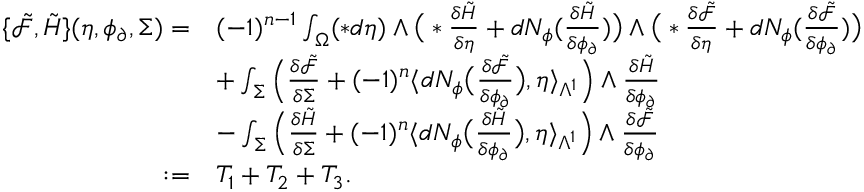<formula> <loc_0><loc_0><loc_500><loc_500>\begin{array} { r l } { \{ \tilde { \mathcal { F } } , \tilde { H } \} ( \eta , \phi _ { \partial } , \Sigma ) = } & { ( - 1 ) ^ { n - 1 } \int _ { \Omega } ( \ast d \eta ) \wedge \left ( \ast \frac { \delta \tilde { H } } { \delta \eta } + d N _ { \phi } ( \frac { \delta \tilde { H } } { \delta \phi _ { \partial } } ) \right ) \wedge \left ( \ast \frac { \delta \tilde { \mathcal { F } } } { \delta \eta } + d N _ { \phi } ( \frac { \delta \tilde { \mathcal { F } } } { \delta \phi _ { \partial } } ) \right ) } \\ & { + \int _ { \Sigma } \left ( \frac { \delta \tilde { \mathcal { F } } } { \delta \Sigma } + ( - 1 ) ^ { n } \langle d N _ { \phi } \left ( \frac { \delta \tilde { \mathcal { F } } } { \delta \phi _ { \partial } } \right ) , \eta \rangle _ { \Lambda ^ { 1 } } \right ) \wedge \frac { \delta \tilde { H } } { \delta \phi _ { \partial } } } \\ & { - \int _ { \Sigma } \left ( \frac { \delta \tilde { H } } { \delta \Sigma } + ( - 1 ) ^ { n } \langle d N _ { \phi } \left ( \frac { \delta \tilde { H } } { \delta \phi _ { \partial } } \right ) , \eta \rangle _ { \Lambda ^ { 1 } } \right ) \wedge \frac { \delta \tilde { \mathcal { F } } } { \delta \phi _ { \partial } } } \\ { \colon = } & { T _ { 1 } + T _ { 2 } + T _ { 3 } . } \end{array}</formula> 